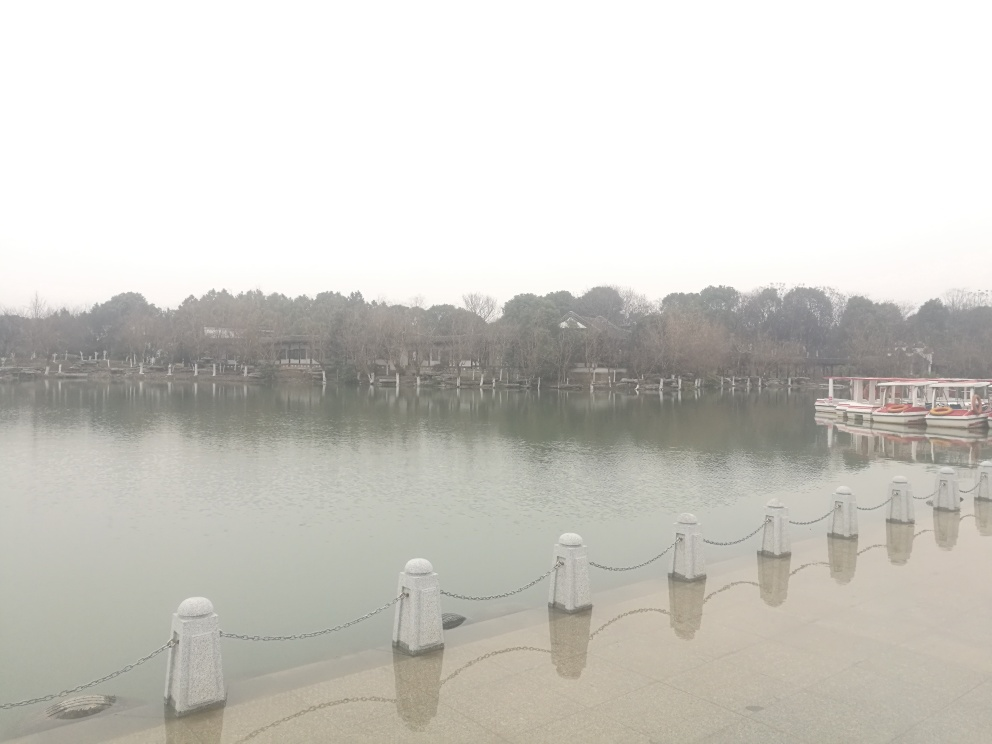Is the overall clarity of the image average? Based on the image's luminosity and focus, the clarity can indeed be considered average. Despite the overcast weather, details such as the trees, boats, and chain railing are distinguishable. However, overall image vibrancy is lacking, possibly due to the diffuse lighting conditions. 